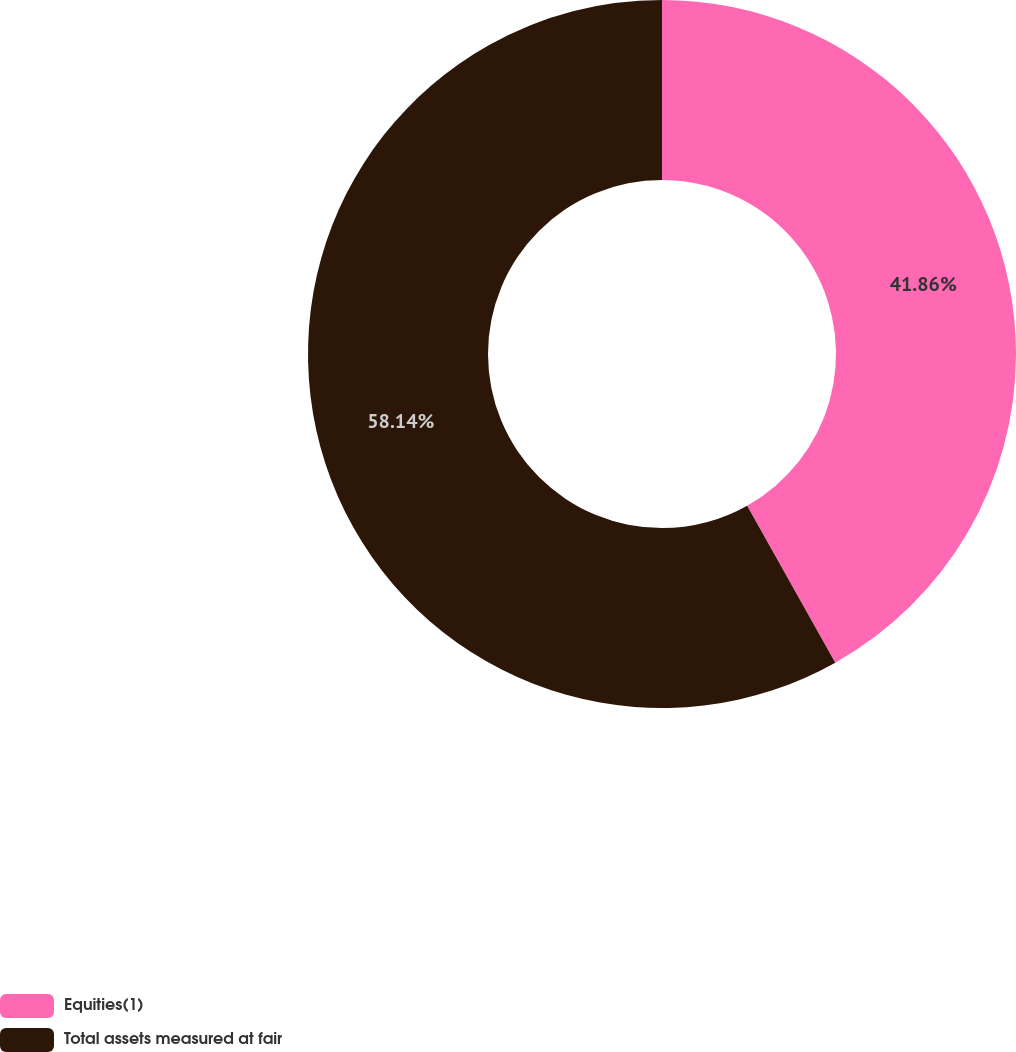Convert chart. <chart><loc_0><loc_0><loc_500><loc_500><pie_chart><fcel>Equities(1)<fcel>Total assets measured at fair<nl><fcel>41.86%<fcel>58.14%<nl></chart> 